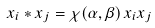<formula> <loc_0><loc_0><loc_500><loc_500>x _ { i } * x _ { j } = \chi ( \alpha , \beta ) \, x _ { i } x _ { j }</formula> 